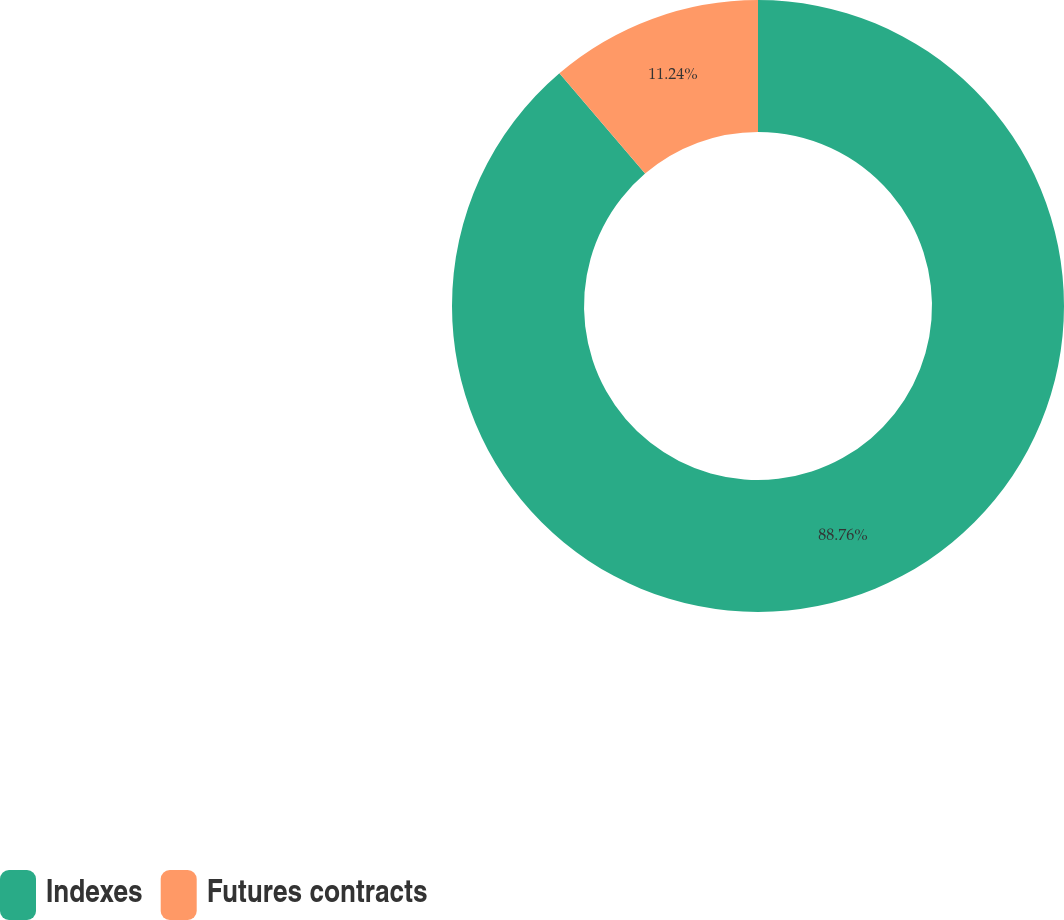Convert chart to OTSL. <chart><loc_0><loc_0><loc_500><loc_500><pie_chart><fcel>Indexes<fcel>Futures contracts<nl><fcel>88.76%<fcel>11.24%<nl></chart> 